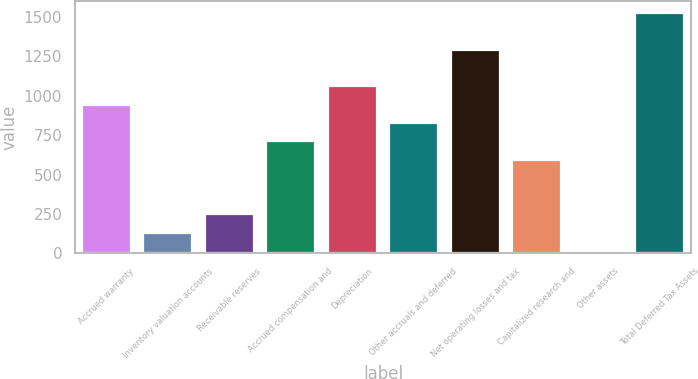Convert chart. <chart><loc_0><loc_0><loc_500><loc_500><bar_chart><fcel>Accrued warranty<fcel>Inventory valuation accounts<fcel>Receivable reserves<fcel>Accrued compensation and<fcel>Depreciation<fcel>Other accruals and deferred<fcel>Net operating losses and tax<fcel>Capitalized research and<fcel>Other assets<fcel>Total Deferred Tax Assets<nl><fcel>944.4<fcel>130.3<fcel>246.6<fcel>711.8<fcel>1060.7<fcel>828.1<fcel>1293.3<fcel>595.5<fcel>14<fcel>1525.9<nl></chart> 